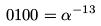<formula> <loc_0><loc_0><loc_500><loc_500>0 1 0 0 = \alpha ^ { - 1 3 }</formula> 